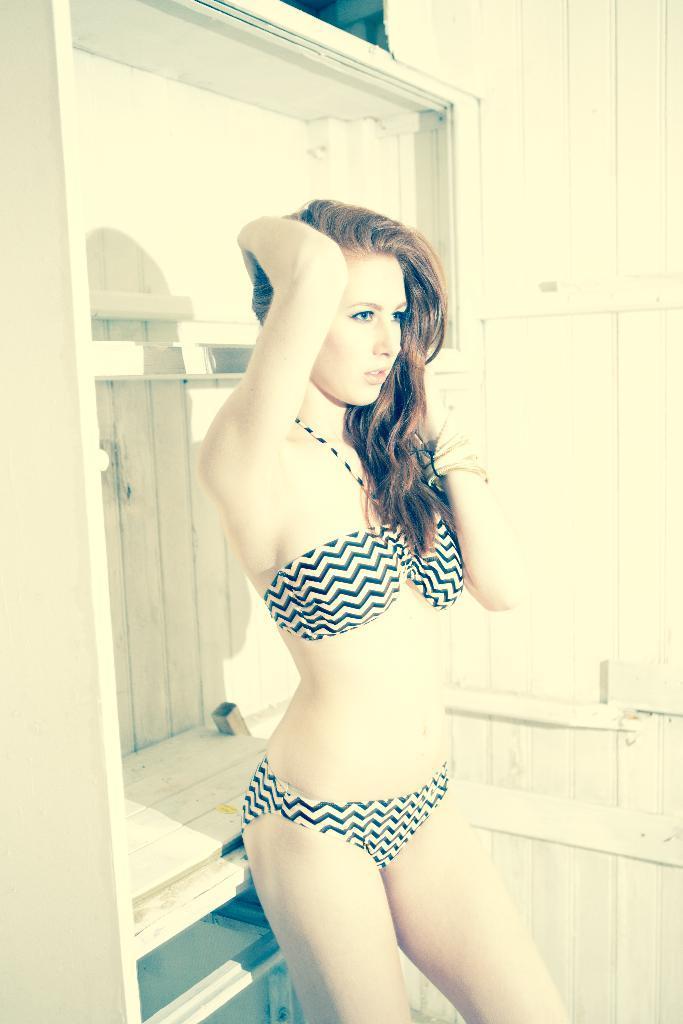In one or two sentences, can you explain what this image depicts? In this picture I can observe a woman in the middle of the picture. In the background I can observe a wooden wall. 